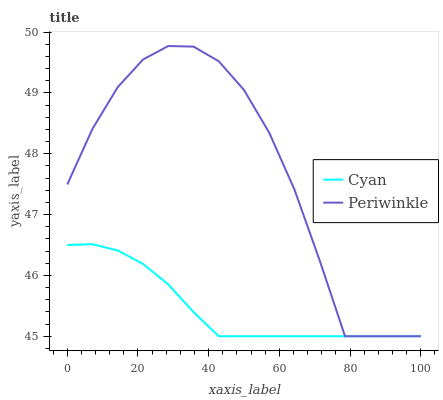Does Cyan have the minimum area under the curve?
Answer yes or no. Yes. Does Periwinkle have the maximum area under the curve?
Answer yes or no. Yes. Does Periwinkle have the minimum area under the curve?
Answer yes or no. No. Is Cyan the smoothest?
Answer yes or no. Yes. Is Periwinkle the roughest?
Answer yes or no. Yes. Is Periwinkle the smoothest?
Answer yes or no. No. Does Cyan have the lowest value?
Answer yes or no. Yes. Does Periwinkle have the highest value?
Answer yes or no. Yes. Does Cyan intersect Periwinkle?
Answer yes or no. Yes. Is Cyan less than Periwinkle?
Answer yes or no. No. Is Cyan greater than Periwinkle?
Answer yes or no. No. 